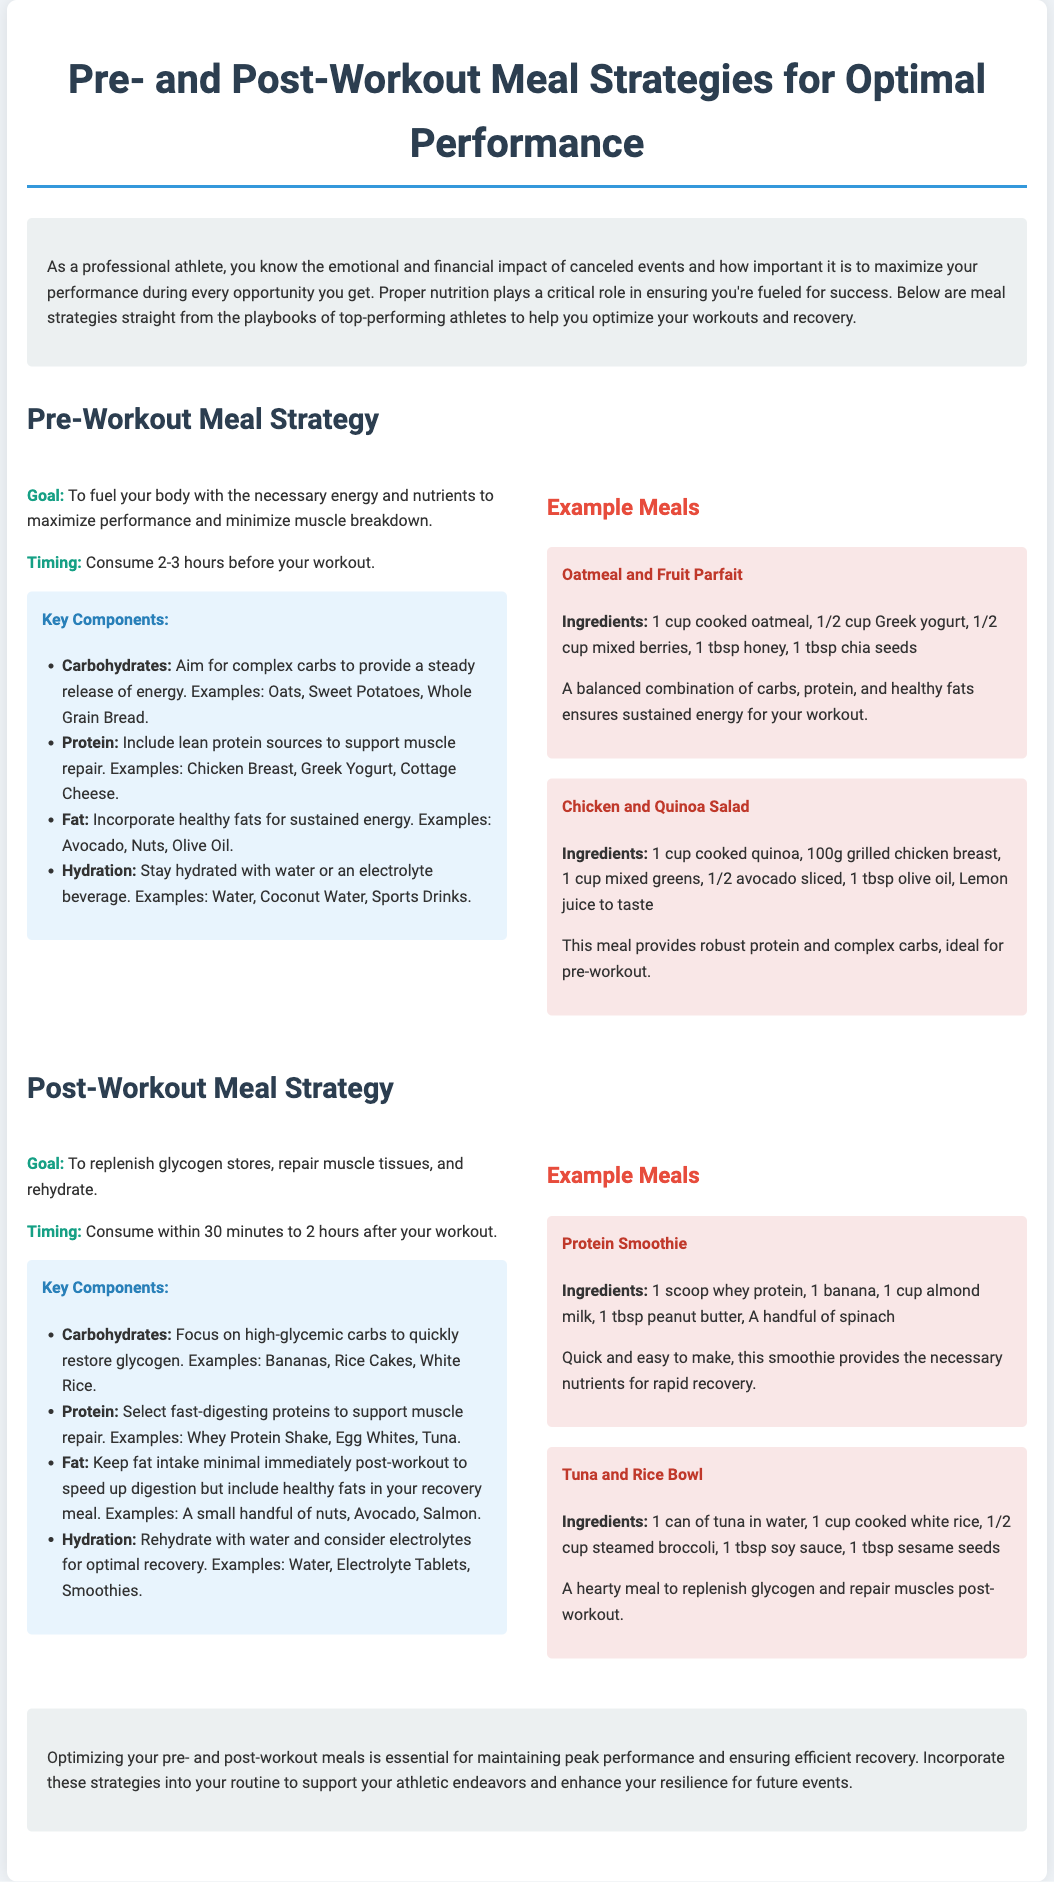What is the goal of the pre-workout meal strategy? The goal is to fuel your body with the necessary energy and nutrients to maximize performance and minimize muscle breakdown.
Answer: To fuel your body with the necessary energy and nutrients to maximize performance and minimize muscle breakdown What is one example of a complex carbohydrate recommended for pre-workout? The document lists oats, sweet potatoes, and whole grain bread as examples of complex carbohydrates.
Answer: Oats When should a post-workout meal be consumed? The timing is specified as within 30 minutes to 2 hours after your workout.
Answer: Within 30 minutes to 2 hours What type of protein is recommended for post-workout? The document advises to select fast-digesting proteins for muscle repair.
Answer: Fast-digesting proteins Name one ingredient in the Oatmeal and Fruit Parfait. The recipe includes cooked oatmeal, Greek yogurt, mixed berries, honey, and chia seeds.
Answer: Cooked oatmeal What is recommended for hydration pre-workout? Staying hydrated with water or an electrolyte beverage is advised.
Answer: Water or an electrolyte beverage Why is it suggested to keep fat intake minimal immediately post-workout? To speed up digestion but include healthy fats in your recovery meal later.
Answer: To speed up digestion What is the timing for consuming the pre-workout meal? The document specifies to consume it 2-3 hours before your workout.
Answer: 2-3 hours before your workout What is one example of a high-glycemic carbohydrate for post-workout? The document lists bananas, rice cakes, and white rice as examples.
Answer: Bananas 